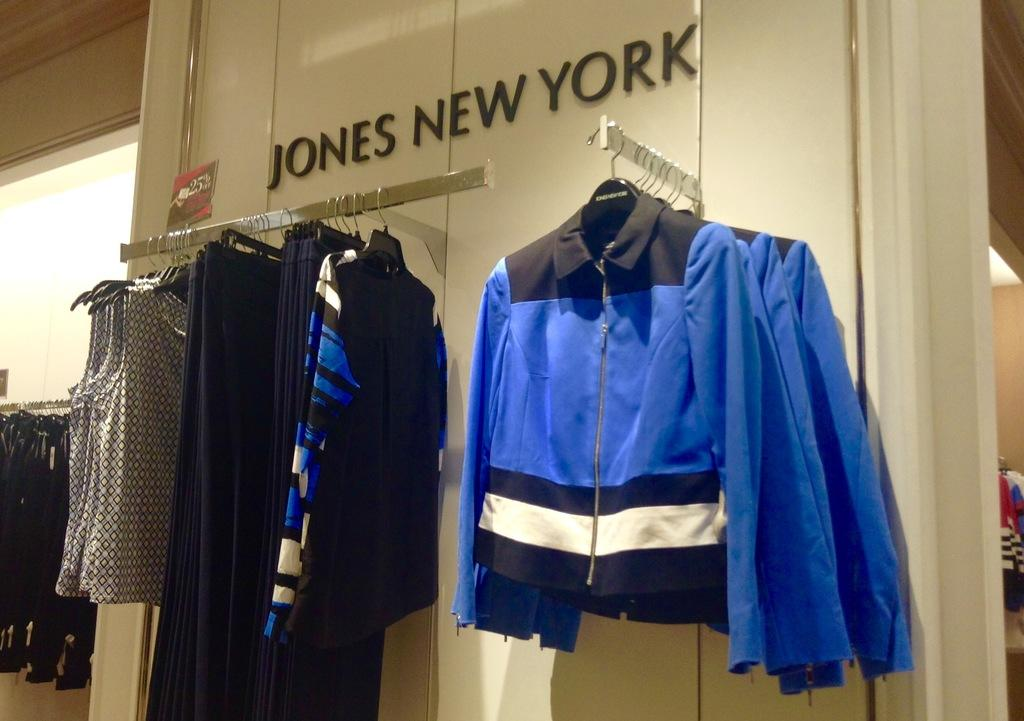Provide a one-sentence caption for the provided image. Jones New York sells different types of articles of clothes. 